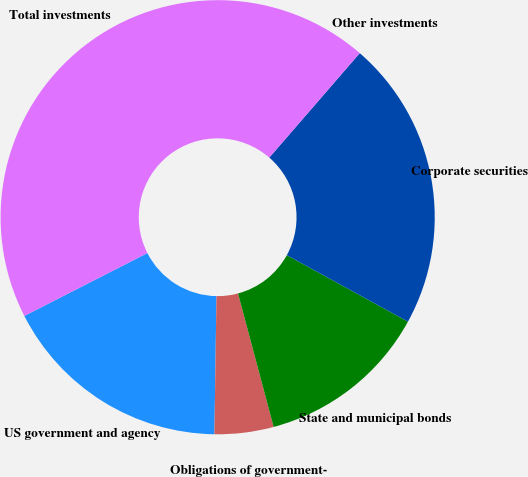Convert chart to OTSL. <chart><loc_0><loc_0><loc_500><loc_500><pie_chart><fcel>US government and agency<fcel>Obligations of government-<fcel>State and municipal bonds<fcel>Corporate securities<fcel>Other investments<fcel>Total investments<nl><fcel>17.25%<fcel>4.39%<fcel>12.86%<fcel>21.63%<fcel>0.0%<fcel>43.87%<nl></chart> 